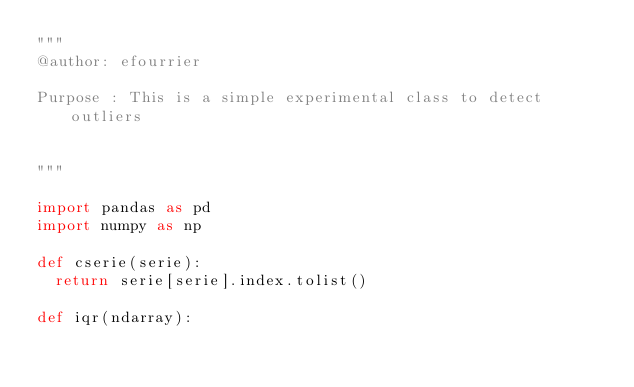<code> <loc_0><loc_0><loc_500><loc_500><_Python_>"""
@author: efourrier

Purpose : This is a simple experimental class to detect outliers 


"""

import pandas as pd 
import numpy as np 

def cserie(serie):
	return serie[serie].index.tolist()

def iqr(ndarray):</code> 